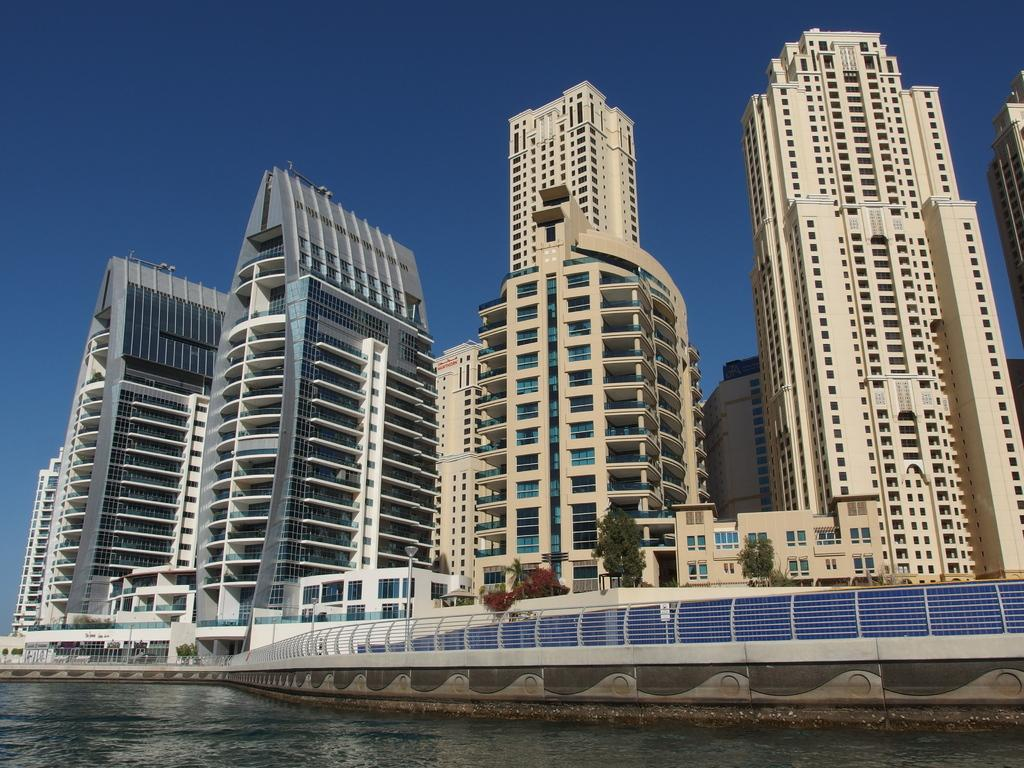What type of structures can be seen in the image? There are buildings in the image. What natural element is visible in the image? There is water visible in the image. What type of vegetation is present in the image? There are trees in the image. What type of barrier can be seen in the image? There is a metal fence in the image. What type of lighting is present in the image? There are pole lights in the image. What is the color of the sky in the image? The sky is blue in the image. Can you tell me how many hens are present in the image? There are no hens present in the image. What type of education is being provided in the image? There is no indication of any educational activity in the image. 